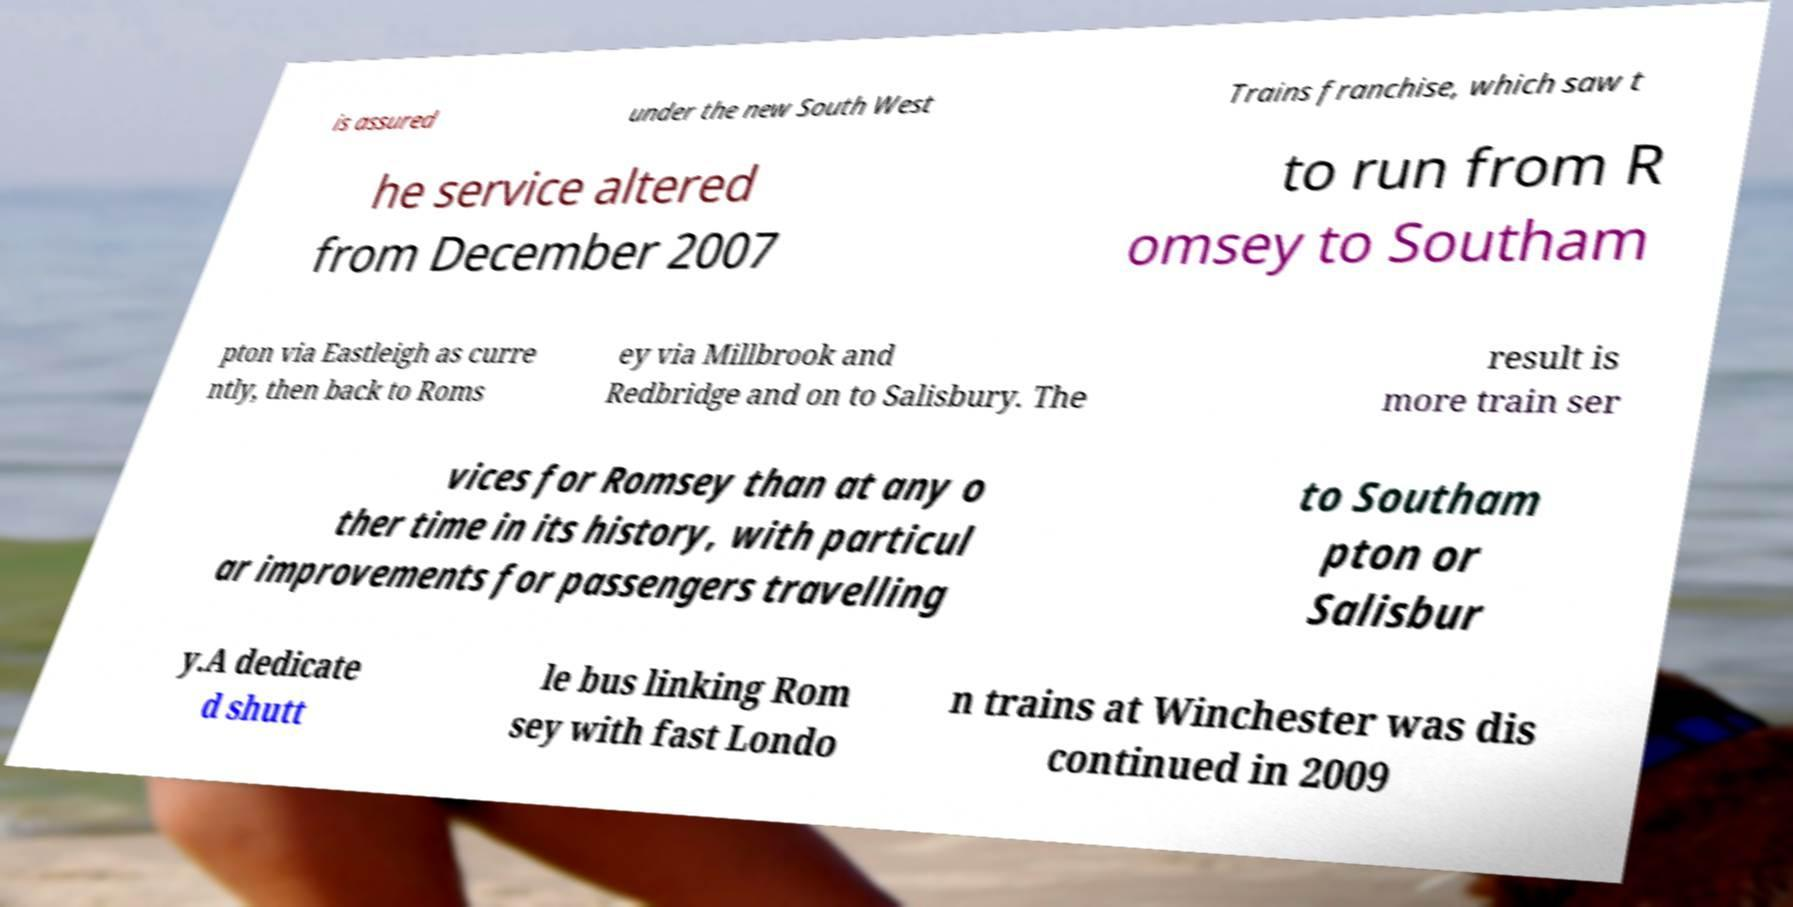Could you assist in decoding the text presented in this image and type it out clearly? is assured under the new South West Trains franchise, which saw t he service altered from December 2007 to run from R omsey to Southam pton via Eastleigh as curre ntly, then back to Roms ey via Millbrook and Redbridge and on to Salisbury. The result is more train ser vices for Romsey than at any o ther time in its history, with particul ar improvements for passengers travelling to Southam pton or Salisbur y.A dedicate d shutt le bus linking Rom sey with fast Londo n trains at Winchester was dis continued in 2009 